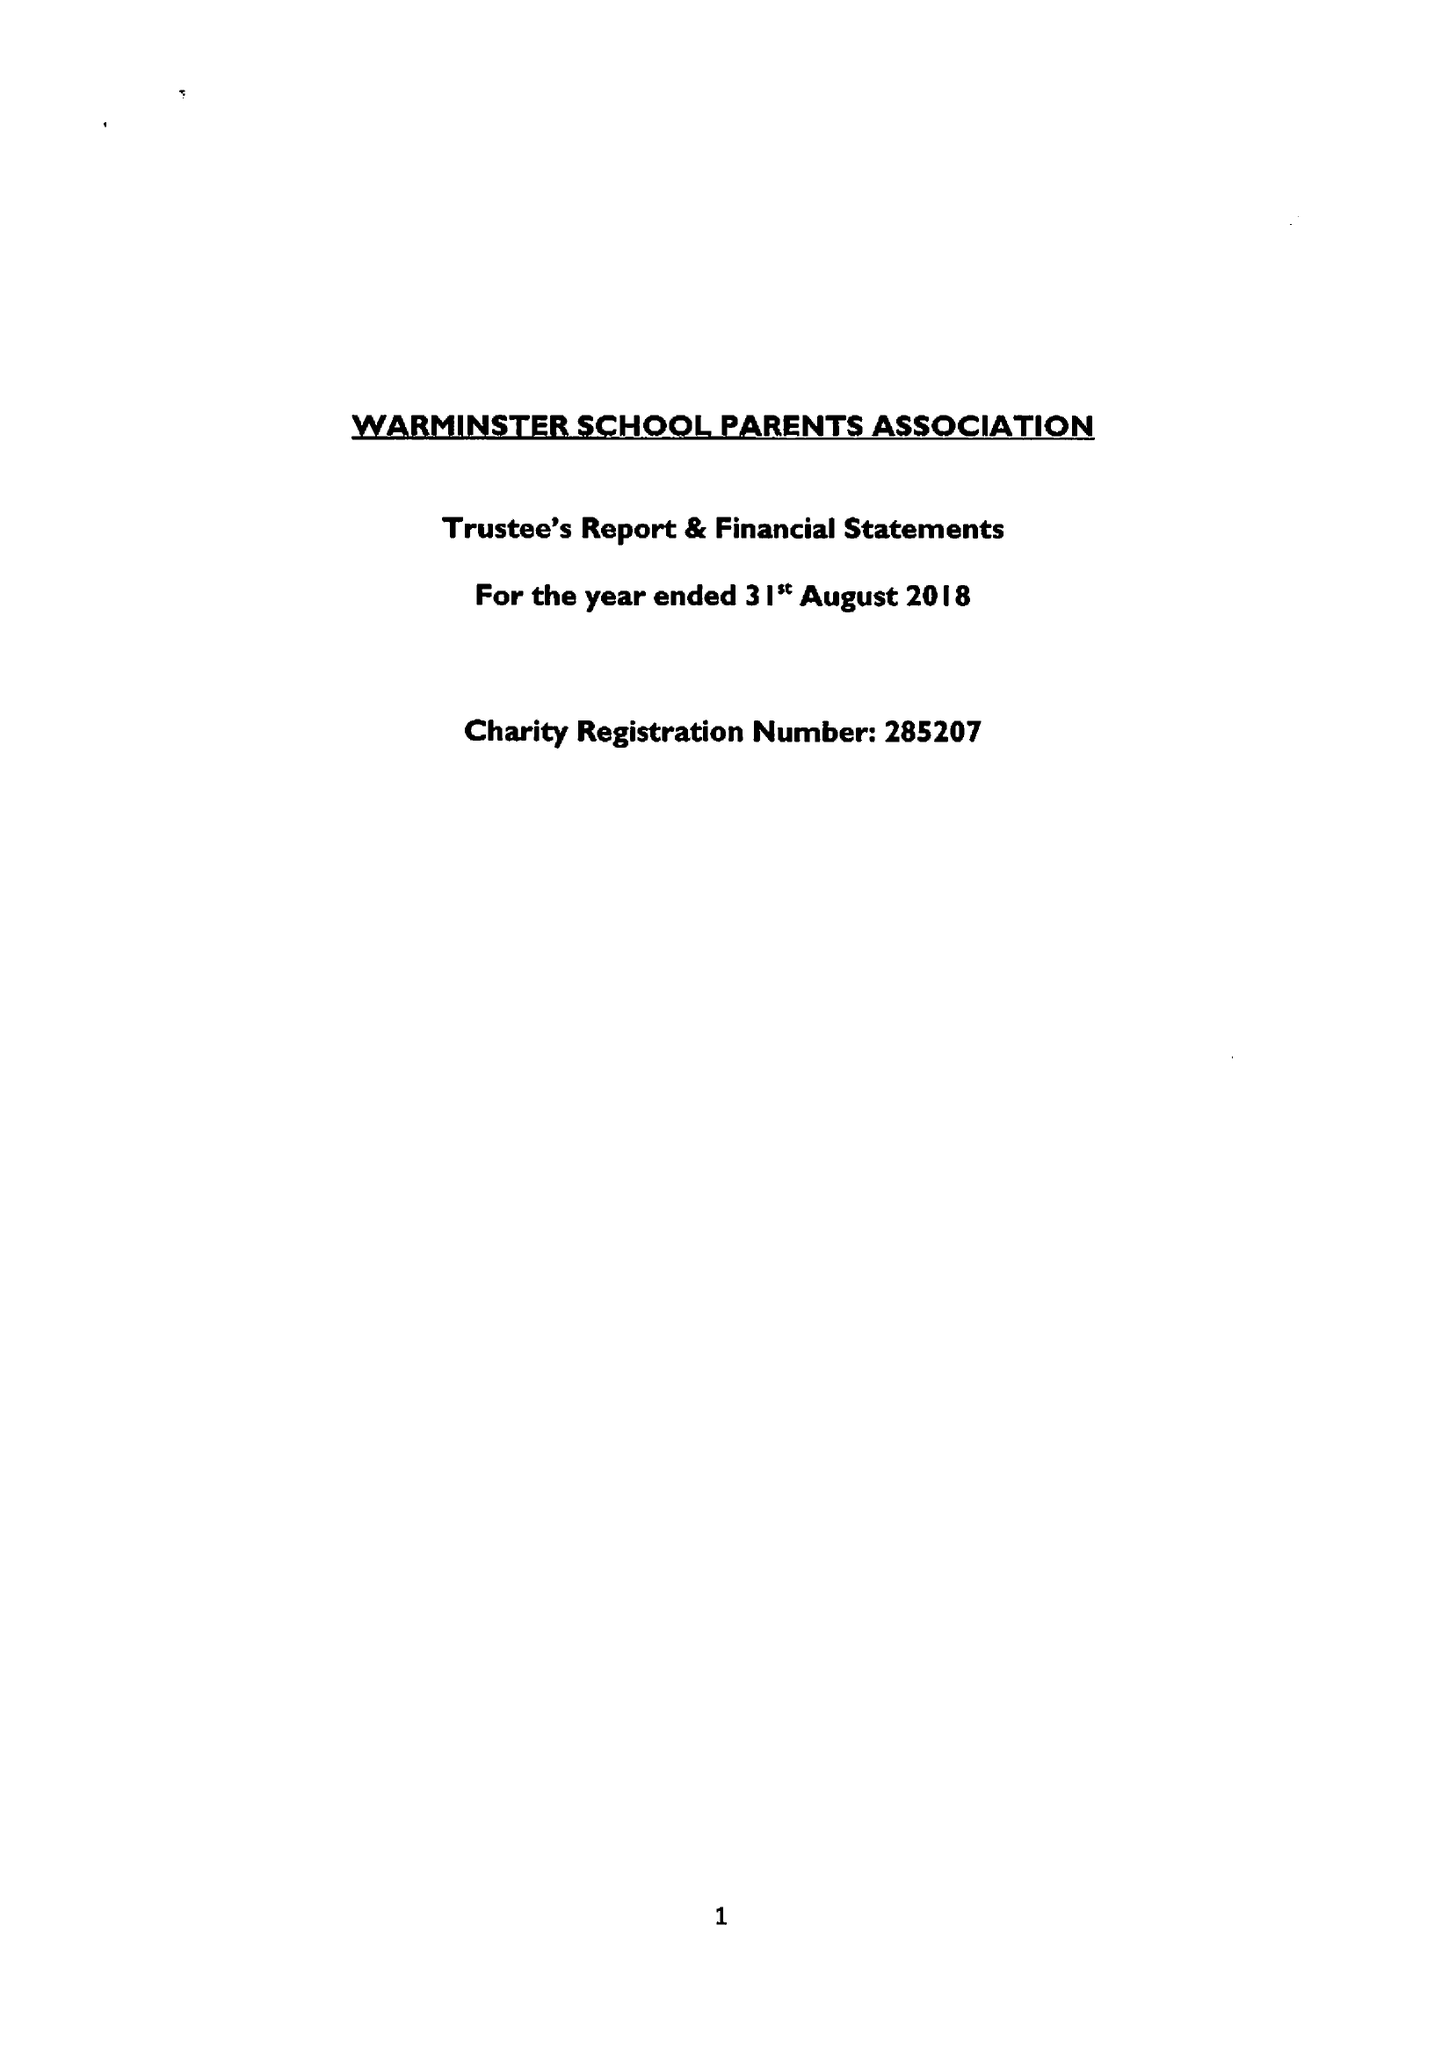What is the value for the address__post_town?
Answer the question using a single word or phrase. WARMINSTER 